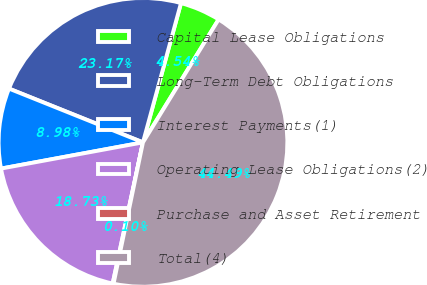Convert chart. <chart><loc_0><loc_0><loc_500><loc_500><pie_chart><fcel>Capital Lease Obligations<fcel>Long-Term Debt Obligations<fcel>Interest Payments(1)<fcel>Operating Lease Obligations(2)<fcel>Purchase and Asset Retirement<fcel>Total(4)<nl><fcel>4.54%<fcel>23.17%<fcel>8.98%<fcel>18.73%<fcel>0.1%<fcel>44.49%<nl></chart> 